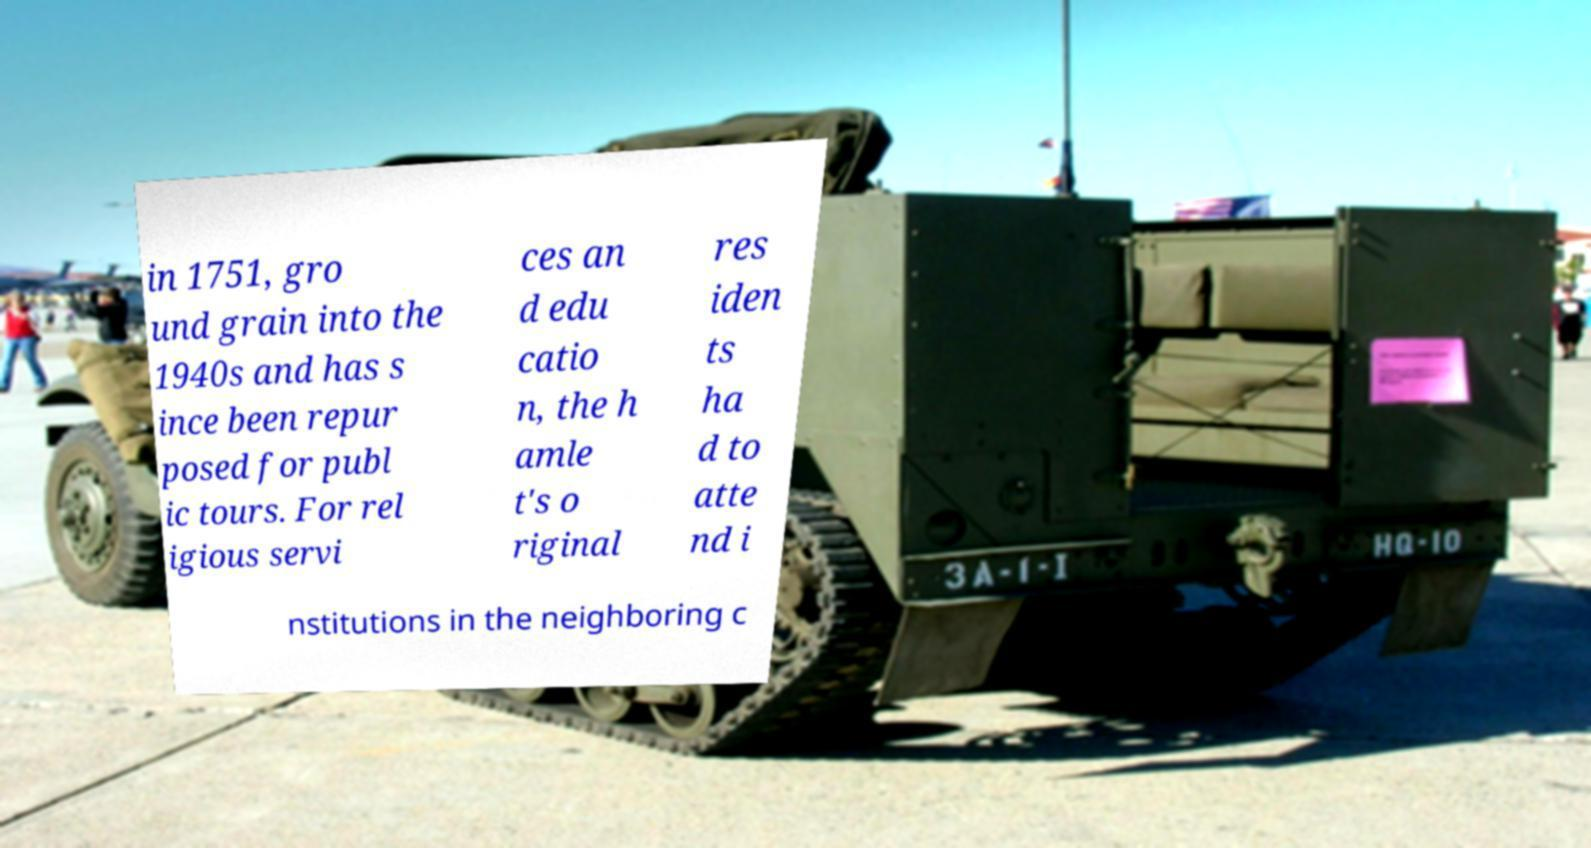Can you accurately transcribe the text from the provided image for me? in 1751, gro und grain into the 1940s and has s ince been repur posed for publ ic tours. For rel igious servi ces an d edu catio n, the h amle t's o riginal res iden ts ha d to atte nd i nstitutions in the neighboring c 